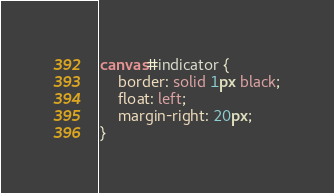<code> <loc_0><loc_0><loc_500><loc_500><_CSS_>canvas#indicator {
	border: solid 1px black;
	float: left;
	margin-right: 20px;
}
</code> 